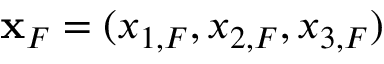Convert formula to latex. <formula><loc_0><loc_0><loc_500><loc_500>{ x } _ { F } = ( x _ { 1 , F } , x _ { 2 , F } , x _ { 3 , F } )</formula> 